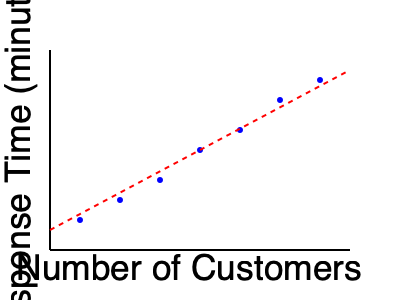Based on the scatter plot showing the relationship between the number of customers and customer service response times, estimate the response time when there are 150 customers. To estimate the response time for 150 customers, we need to follow these steps:

1. Observe the trend in the scatter plot. The red dashed line represents the general trend of the data points.

2. Locate the position on the x-axis that corresponds to 150 customers. This would be roughly halfway between 100 and 200 on the x-axis.

3. From this point, move vertically until you intersect with the red trend line.

4. From the intersection point, move horizontally to the y-axis to estimate the response time.

5. The intersection point appears to be slightly above the midpoint between 10 and 15 minutes on the y-axis.

Therefore, we can estimate that for 150 customers, the response time would be approximately 13-14 minutes.

This estimation method allows us to make a reasonable prediction based on the overall trend of the data, which is crucial for planning customer service resources as the business expands.
Answer: Approximately 13-14 minutes 